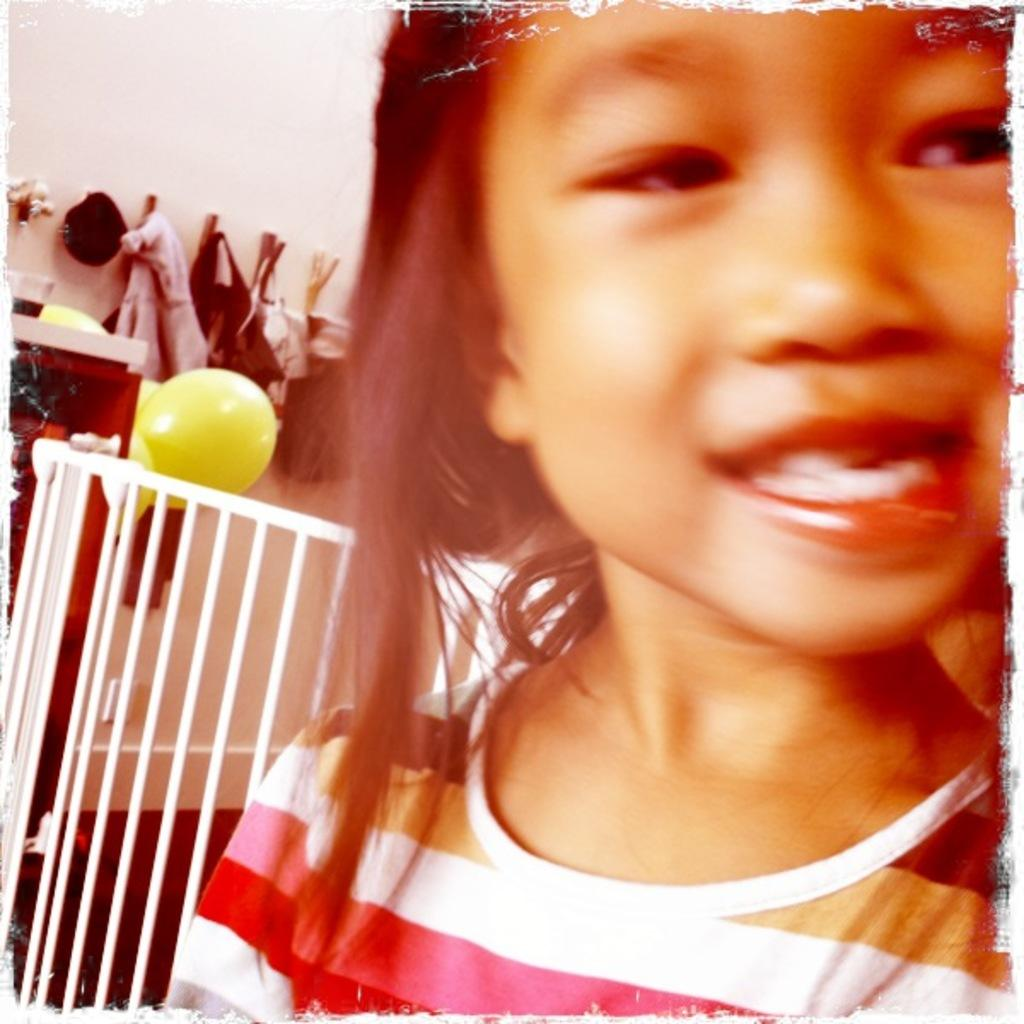Who is the main subject in the image? There is a girl in the center of the image. What can be seen in the background of the image? There are clothes, balloons, and a wall in the background of the image. Is there a man making a payment to the girl in the image? There is no man or payment present in the image; it only features a girl and objects in the background. 